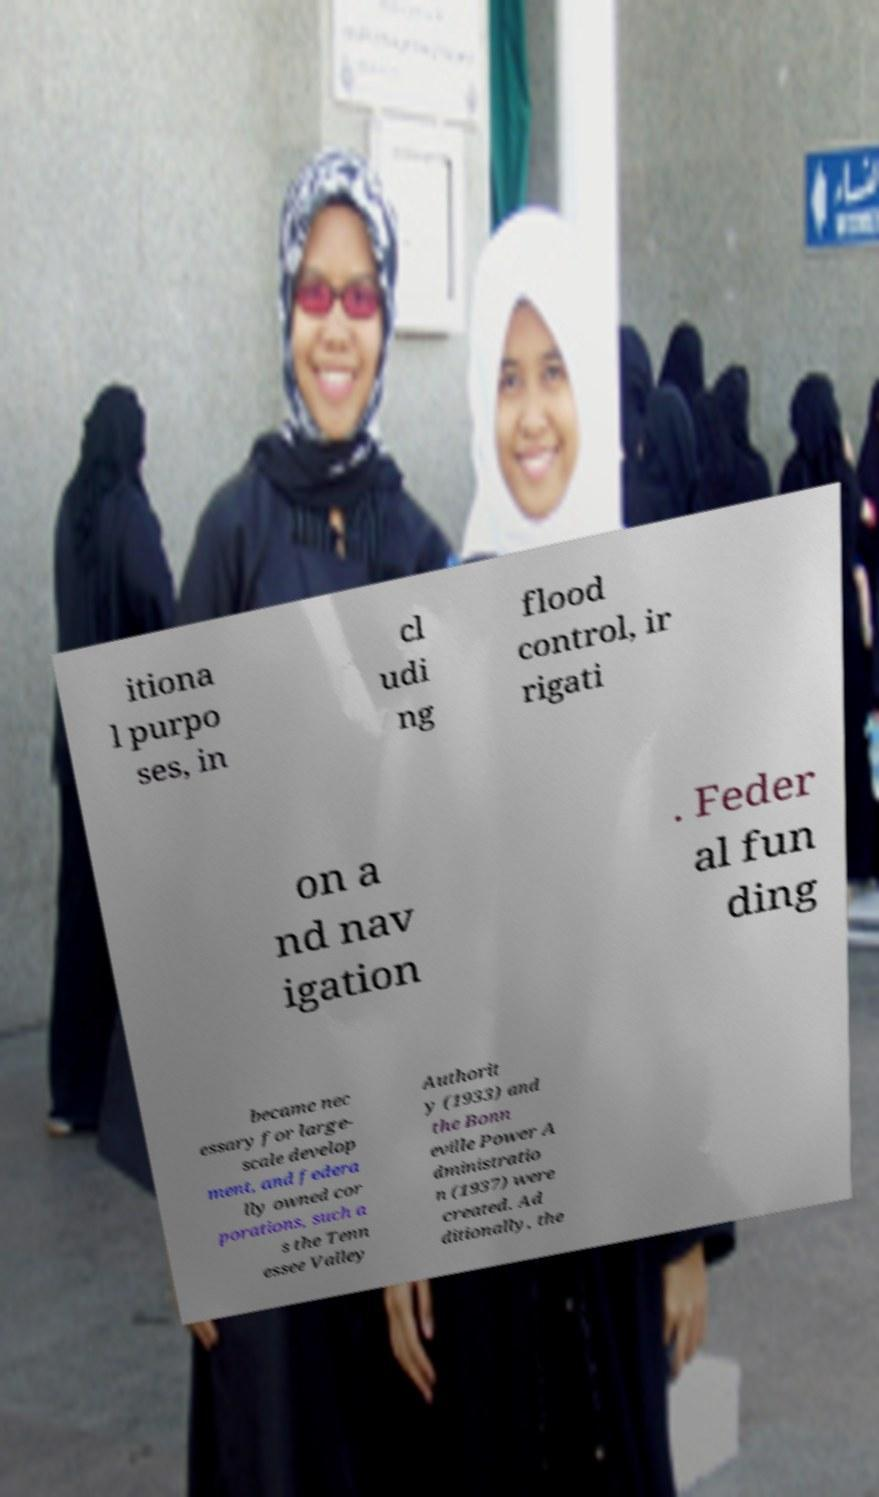Please identify and transcribe the text found in this image. itiona l purpo ses, in cl udi ng flood control, ir rigati on a nd nav igation . Feder al fun ding became nec essary for large- scale develop ment, and federa lly owned cor porations, such a s the Tenn essee Valley Authorit y (1933) and the Bonn eville Power A dministratio n (1937) were created. Ad ditionally, the 